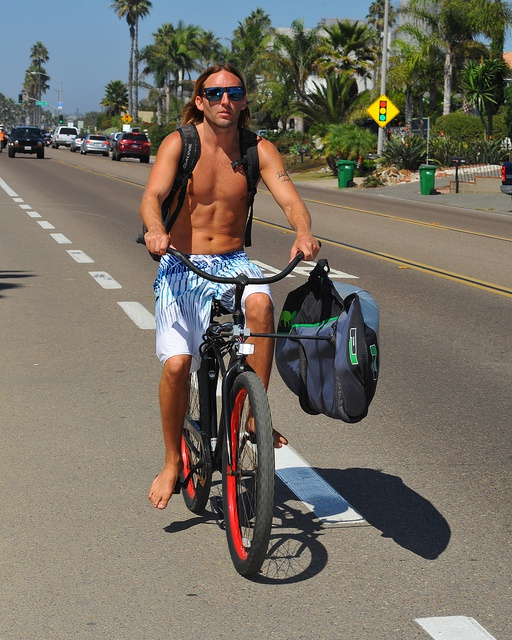Describe the objects in this image and their specific colors. I can see people in darkgray, black, maroon, salmon, and brown tones, bicycle in darkgray, black, gray, and lightgray tones, backpack in darkgray, black, and gray tones, backpack in darkgray, black, maroon, gray, and brown tones, and truck in darkgray, black, gray, and navy tones in this image. 